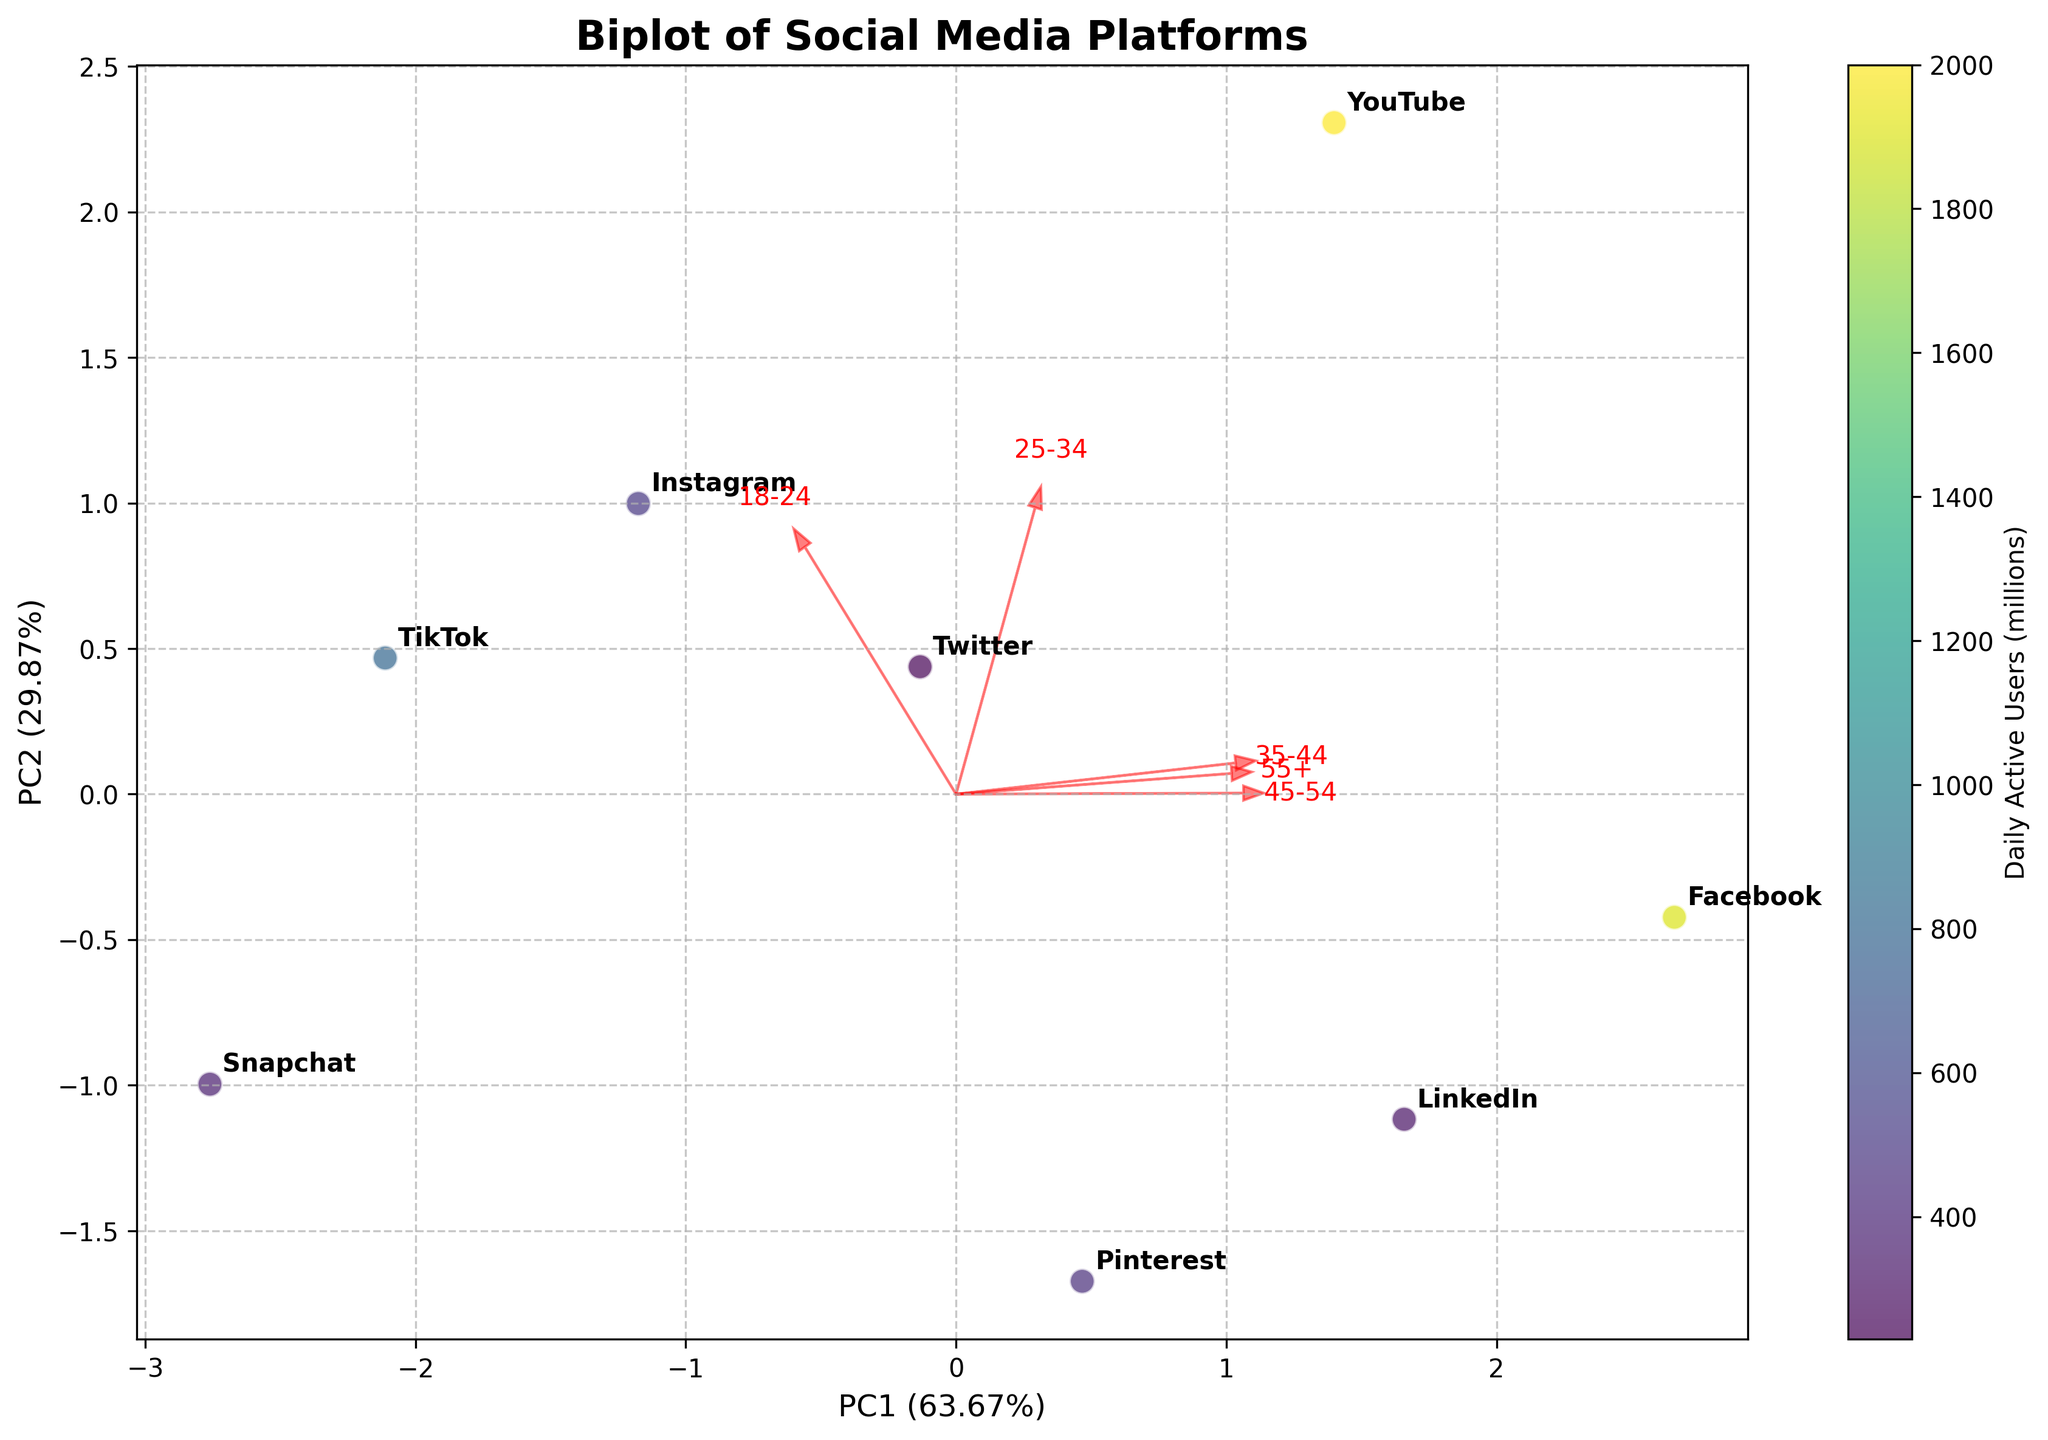What is the title of the plot? The title is usually displayed at the top of the plot. By looking at the figure, you can read and identify the title.
Answer: Biplot of Social Media Platforms Which social media platform has the highest daily active users? By examining the colorbar and looking for the data point with the darkest color, you can identify the platform. In this case, YouTube has the highest value.
Answer: YouTube What percentage of variance is explained by the first principal component (PC1)? Look at the x-axis label, which shows the percentage of variance explained by PC1. The given value in parentheses indicates the percentage.
Answer: 72.54% Which age group is associated the most with Instagram? Observe the direction of the arrows representing age groups and the platform's position relative to them. Instagram is closest to the 18-24 arrow, indicating a stronger association.
Answer: 18-24 How many social media platforms are included in this analysis? Count the number of annotated points (platforms) in the scatter plot of the biplot.
Answer: 8 Which platform has the lowest ad engagement rate and where is it located on the plot? Check the platform's locations and their distances from arrows. LinkedIn has the lowest ad engagement rate (1.9) and is situated near the lower left of the plot.
Answer: LinkedIn, lower left Which two platforms are most similar based on the biplot visualization? Identify platforms that are clustered closely together. In this figure, Instagram and Snapchat are positioned closely, indicating similarity.
Answer: Instagram and Snapchat Which age groups contribute significantly to PC2, according to the biplot? Look at the direction and length of the arrows pointing towards the y-axis. The age groups 45-54 and 55+ have significant arrows leading towards PC2.
Answer: 45-54 and 55+ What do the arrows represent in the biplot, and why are they important? The arrows represent the original variables (age groups) and their correlation with the principal components. They are important as they show the contribution and influence of each variable in the PCA.
Answer: Age groups, their influence on principal components Which platform appears most associated with older age groups (55+)? Determine which platform is closest to the arrow pointing towards the 55+ age group. Facebook aligns more with older age groups, including 55+.
Answer: Facebook 